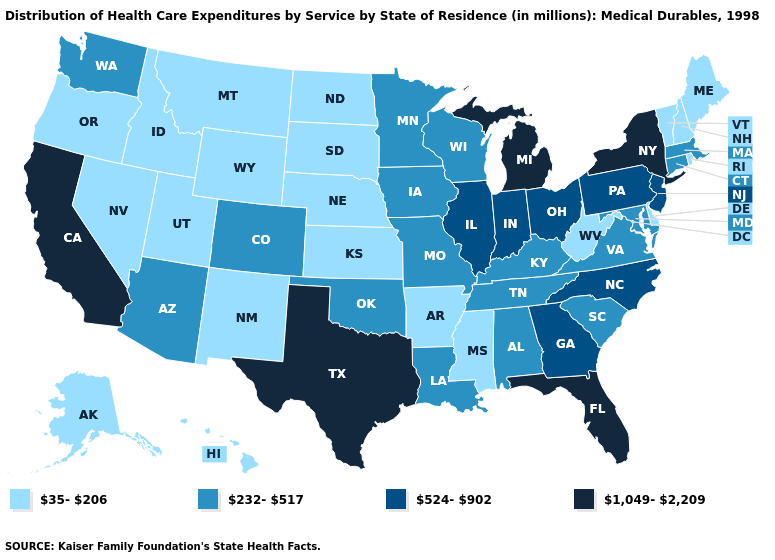Name the states that have a value in the range 524-902?
Be succinct. Georgia, Illinois, Indiana, New Jersey, North Carolina, Ohio, Pennsylvania. Name the states that have a value in the range 35-206?
Quick response, please. Alaska, Arkansas, Delaware, Hawaii, Idaho, Kansas, Maine, Mississippi, Montana, Nebraska, Nevada, New Hampshire, New Mexico, North Dakota, Oregon, Rhode Island, South Dakota, Utah, Vermont, West Virginia, Wyoming. What is the value of Arizona?
Keep it brief. 232-517. Does New Jersey have a higher value than New York?
Answer briefly. No. Name the states that have a value in the range 524-902?
Quick response, please. Georgia, Illinois, Indiana, New Jersey, North Carolina, Ohio, Pennsylvania. What is the value of Oregon?
Answer briefly. 35-206. Which states have the lowest value in the USA?
Quick response, please. Alaska, Arkansas, Delaware, Hawaii, Idaho, Kansas, Maine, Mississippi, Montana, Nebraska, Nevada, New Hampshire, New Mexico, North Dakota, Oregon, Rhode Island, South Dakota, Utah, Vermont, West Virginia, Wyoming. Among the states that border Illinois , does Indiana have the lowest value?
Write a very short answer. No. What is the value of Colorado?
Quick response, please. 232-517. What is the value of Indiana?
Give a very brief answer. 524-902. Name the states that have a value in the range 1,049-2,209?
Answer briefly. California, Florida, Michigan, New York, Texas. Name the states that have a value in the range 1,049-2,209?
Keep it brief. California, Florida, Michigan, New York, Texas. What is the lowest value in the USA?
Short answer required. 35-206. Name the states that have a value in the range 524-902?
Concise answer only. Georgia, Illinois, Indiana, New Jersey, North Carolina, Ohio, Pennsylvania. Is the legend a continuous bar?
Write a very short answer. No. 